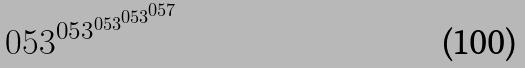Convert formula to latex. <formula><loc_0><loc_0><loc_500><loc_500>0 5 3 ^ { 0 5 3 ^ { 0 5 3 ^ { 0 5 3 ^ { 0 5 7 } } } }</formula> 